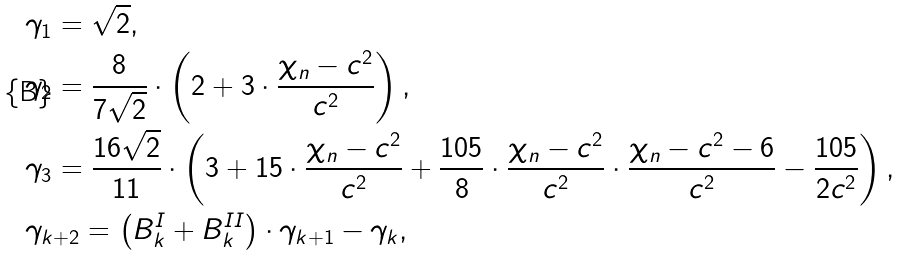Convert formula to latex. <formula><loc_0><loc_0><loc_500><loc_500>& \gamma _ { 1 } = \sqrt { 2 } , \\ & \gamma _ { 2 } = \frac { 8 } { 7 \sqrt { 2 } } \cdot \left ( 2 + 3 \cdot \frac { \chi _ { n } - c ^ { 2 } } { c ^ { 2 } } \right ) , \\ & \gamma _ { 3 } = \frac { 1 6 \sqrt { 2 } } { 1 1 } \cdot \left ( 3 + 1 5 \cdot \frac { \chi _ { n } - c ^ { 2 } } { c ^ { 2 } } + \frac { 1 0 5 } { 8 } \cdot \frac { \chi _ { n } - c ^ { 2 } } { c ^ { 2 } } \cdot \frac { \chi _ { n } - c ^ { 2 } - 6 } { c ^ { 2 } } - \frac { 1 0 5 } { 2 c ^ { 2 } } \right ) , \\ & \gamma _ { k + 2 } = \left ( B ^ { I } _ { k } + B ^ { I I } _ { k } \right ) \cdot \gamma _ { k + 1 } - \gamma _ { k } ,</formula> 